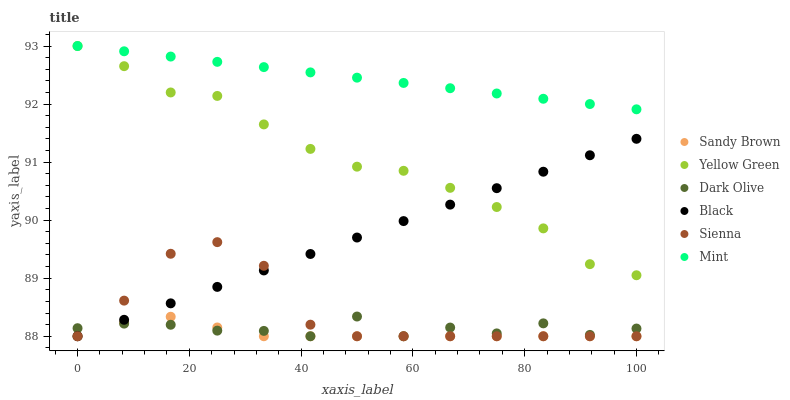Does Sandy Brown have the minimum area under the curve?
Answer yes or no. Yes. Does Mint have the maximum area under the curve?
Answer yes or no. Yes. Does Dark Olive have the minimum area under the curve?
Answer yes or no. No. Does Dark Olive have the maximum area under the curve?
Answer yes or no. No. Is Black the smoothest?
Answer yes or no. Yes. Is Dark Olive the roughest?
Answer yes or no. Yes. Is Mint the smoothest?
Answer yes or no. No. Is Mint the roughest?
Answer yes or no. No. Does Dark Olive have the lowest value?
Answer yes or no. Yes. Does Mint have the lowest value?
Answer yes or no. No. Does Mint have the highest value?
Answer yes or no. Yes. Does Dark Olive have the highest value?
Answer yes or no. No. Is Sienna less than Mint?
Answer yes or no. Yes. Is Yellow Green greater than Dark Olive?
Answer yes or no. Yes. Does Yellow Green intersect Mint?
Answer yes or no. Yes. Is Yellow Green less than Mint?
Answer yes or no. No. Is Yellow Green greater than Mint?
Answer yes or no. No. Does Sienna intersect Mint?
Answer yes or no. No. 